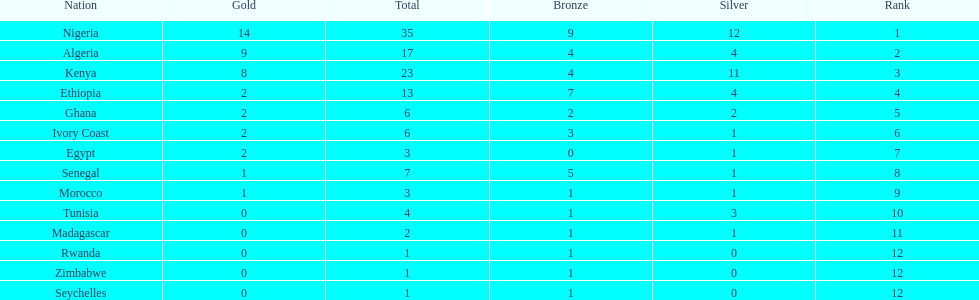Which nations have won only one medal? Rwanda, Zimbabwe, Seychelles. 